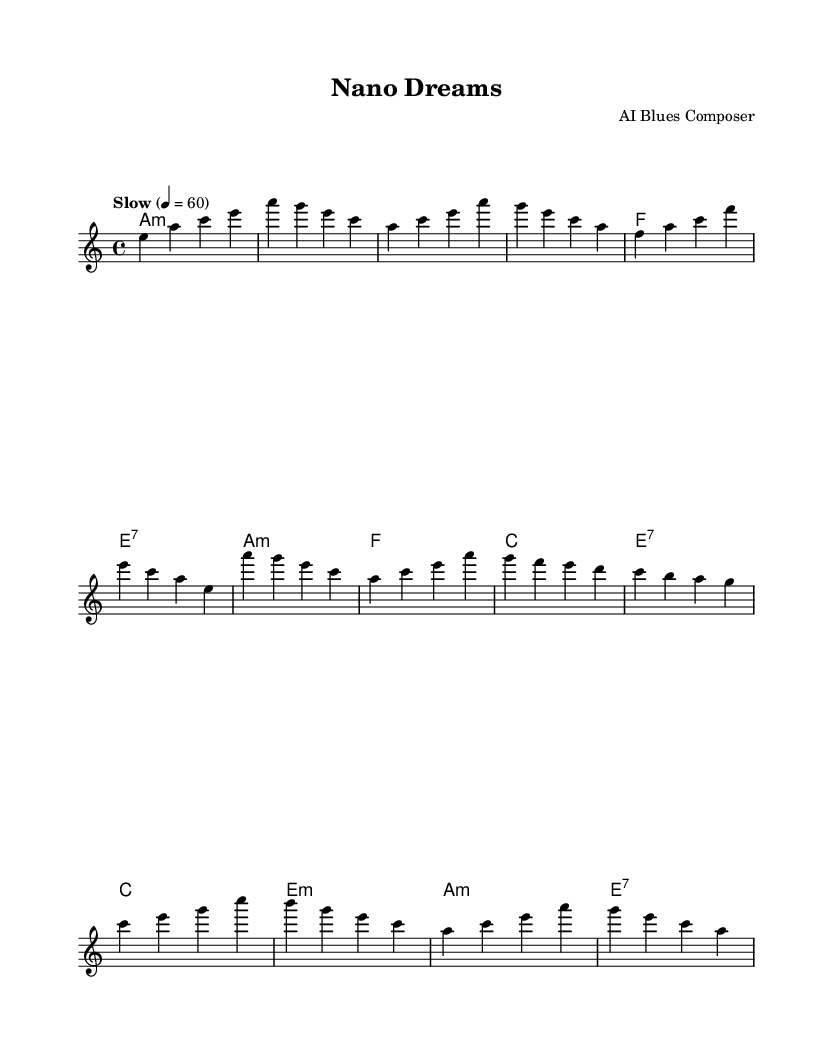What is the key signature of this music? The key signature is indicated at the beginning of the score, which shows the presence of one flat (A minor has no sharps or flats), denoting the key.
Answer: A minor What is the time signature of this music? The time signature is represented at the beginning of the music, which is 4/4, meaning there are four beats in each measure and a quarter note gets one beat.
Answer: 4/4 What tempo marking is used in this piece? The tempo marking is found at the top of the score, which indicates "Slow" with a metronome marking of 60 beats per minute to guide the pace for performance.
Answer: Slow 60 Which chord is used in the bridge? The bridge section contains a specific chord notated in the harmonies section, which is the C major chord as indicated in the chord progression for that part of the music.
Answer: C major How many measures are in the first verse? The first verse is composed of four measures, as can be counted from the beginning of the verse section until it transitions to the chorus.
Answer: Four What is the first note of the melody? The first note of the melody in the piece is indicated within the melody line at the start, which shows the note E as the initial pitch.
Answer: E Is there a repeated chord in the chorus? Observing the chord changes in the chorus section reveals that the A minor chord appears multiple times, indicating a repetition in the harmonic structure of the chorus.
Answer: Yes, A minor 